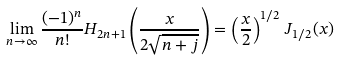<formula> <loc_0><loc_0><loc_500><loc_500>\lim _ { n \to \infty } \frac { ( - 1 ) ^ { n } } { n ! } H _ { 2 n + 1 } \left ( \frac { x } { 2 \sqrt { n + j } } \right ) = \left ( \frac { x } { 2 } \right ) ^ { 1 / 2 } \, J _ { 1 / 2 } ( x )</formula> 